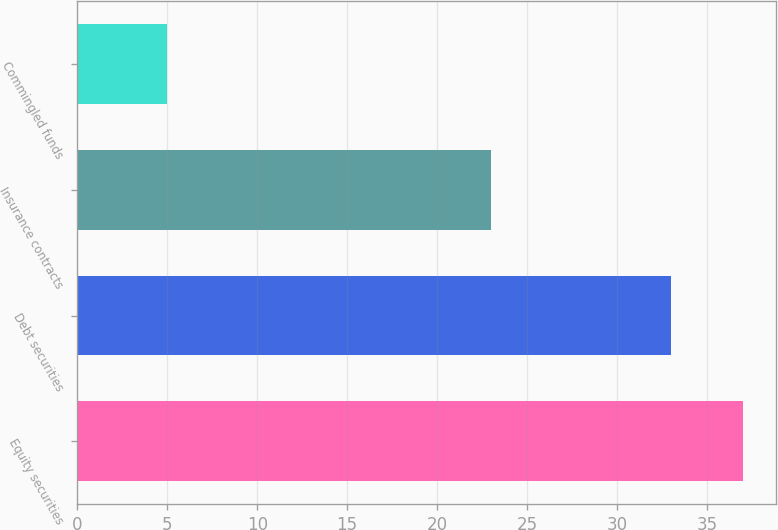<chart> <loc_0><loc_0><loc_500><loc_500><bar_chart><fcel>Equity securities<fcel>Debt securities<fcel>Insurance contracts<fcel>Commingled funds<nl><fcel>37<fcel>33<fcel>23<fcel>5<nl></chart> 